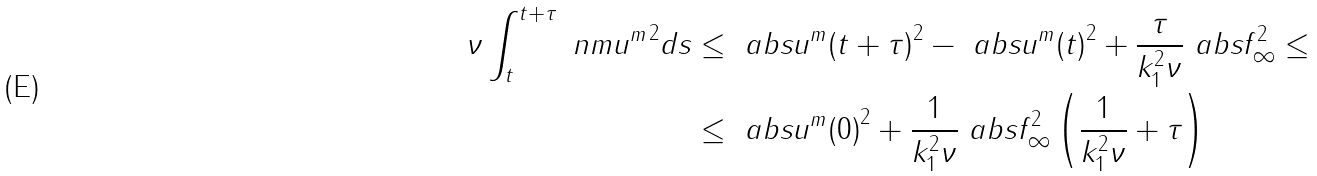Convert formula to latex. <formula><loc_0><loc_0><loc_500><loc_500>\nu \int _ { t } ^ { t + \tau } \ n m { u ^ { m } } ^ { 2 } d s & \leq \ a b s { u ^ { m } ( t + \tau ) } ^ { 2 } - \ a b s { u ^ { m } ( t ) } ^ { 2 } + \frac { \tau } { k _ { 1 } ^ { 2 } \nu } \ a b s { f } _ { \infty } ^ { 2 } \leq \\ & \leq \ a b s { u ^ { m } ( 0 ) } ^ { 2 } + \frac { 1 } { k _ { 1 } ^ { 2 } \nu } \ a b s { f } _ { \infty } ^ { 2 } \left ( \frac { 1 } { k _ { 1 } ^ { 2 } \nu } + \tau \right )</formula> 